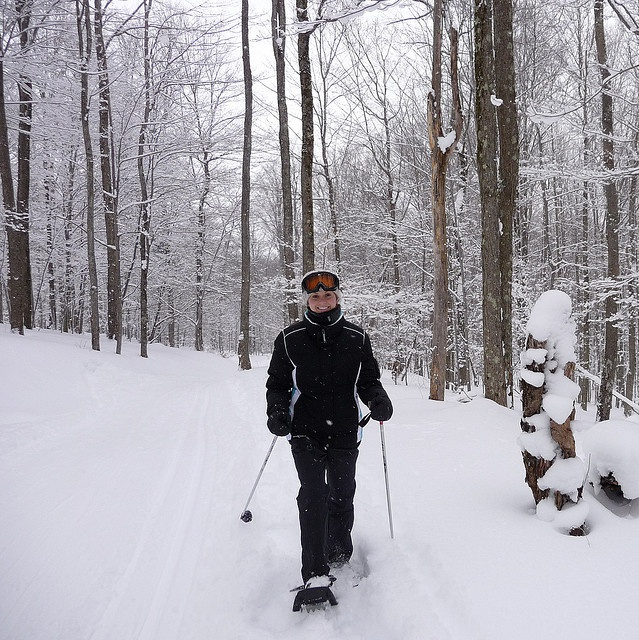Describe the objects in this image and their specific colors. I can see people in gray, black, darkgray, and lightgray tones in this image. 